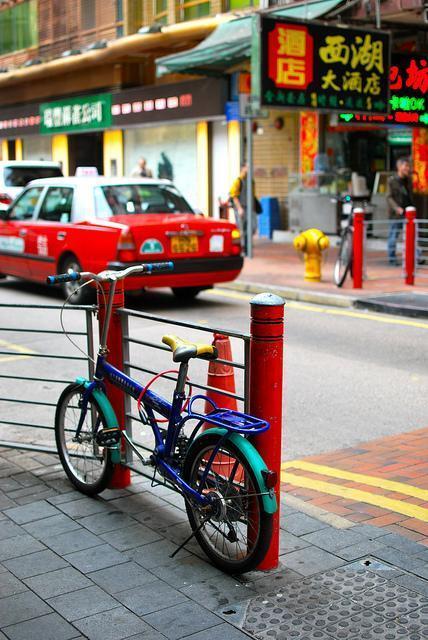How many yellow poles are there?
Give a very brief answer. 0. 